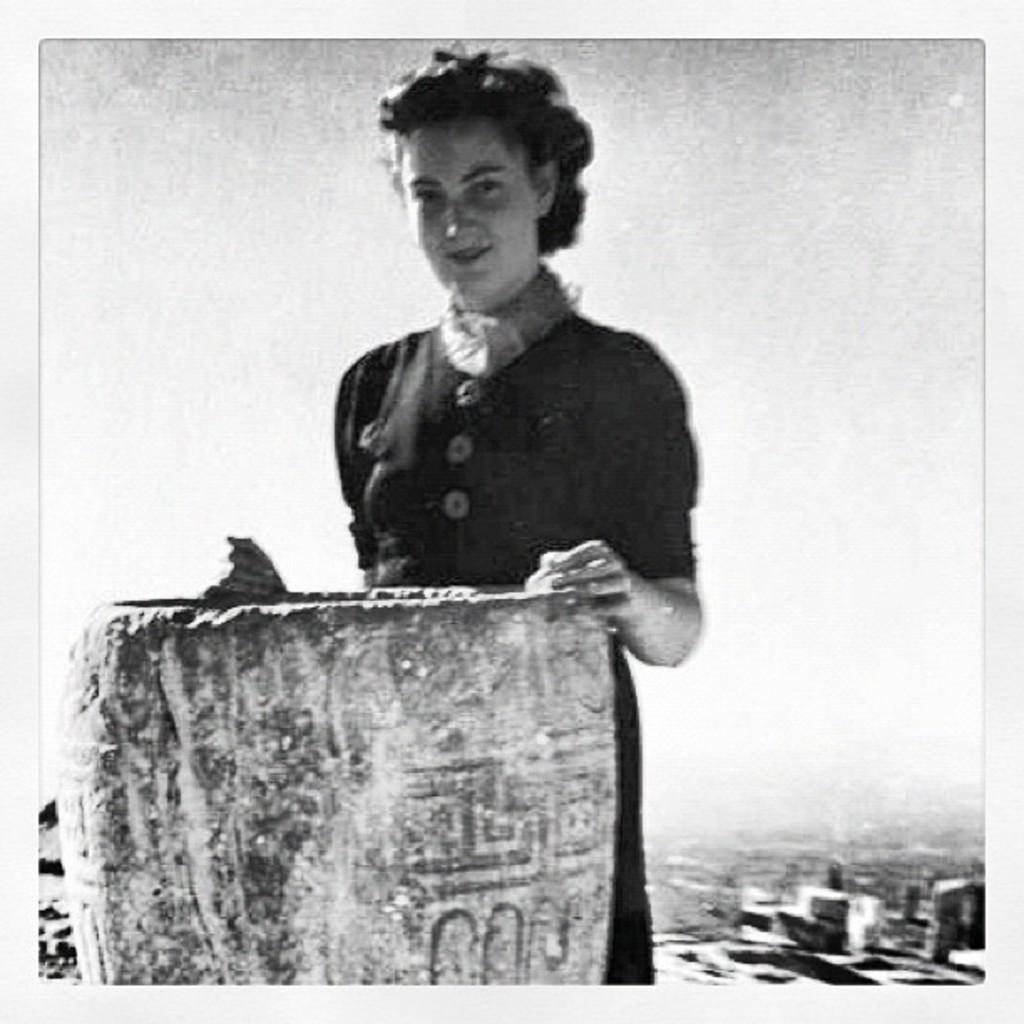Who is present in the image? There is a woman in the image. What is the woman wearing? The woman is wearing a black dress. What is the woman's facial expression? The woman is smiling. What type of natural elements can be seen in the image? There are stones visible in the image. Can you describe the background of the image? The background of the image is blurred. What type of rake is the woman holding in the image? There is no rake present in the image. 